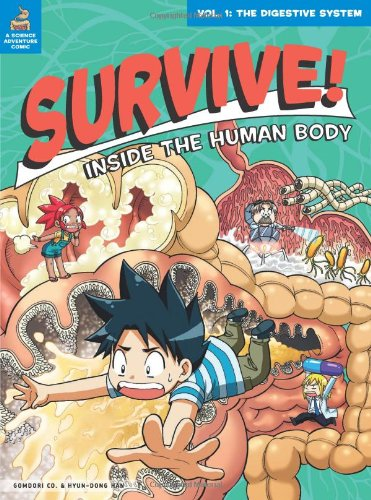Who is the author of this book? The book lists 'Gomdori co.' and illustrator Hyun-Dong Han as the creators. In educational texts like this, the publisher is sometimes credited as the author. 